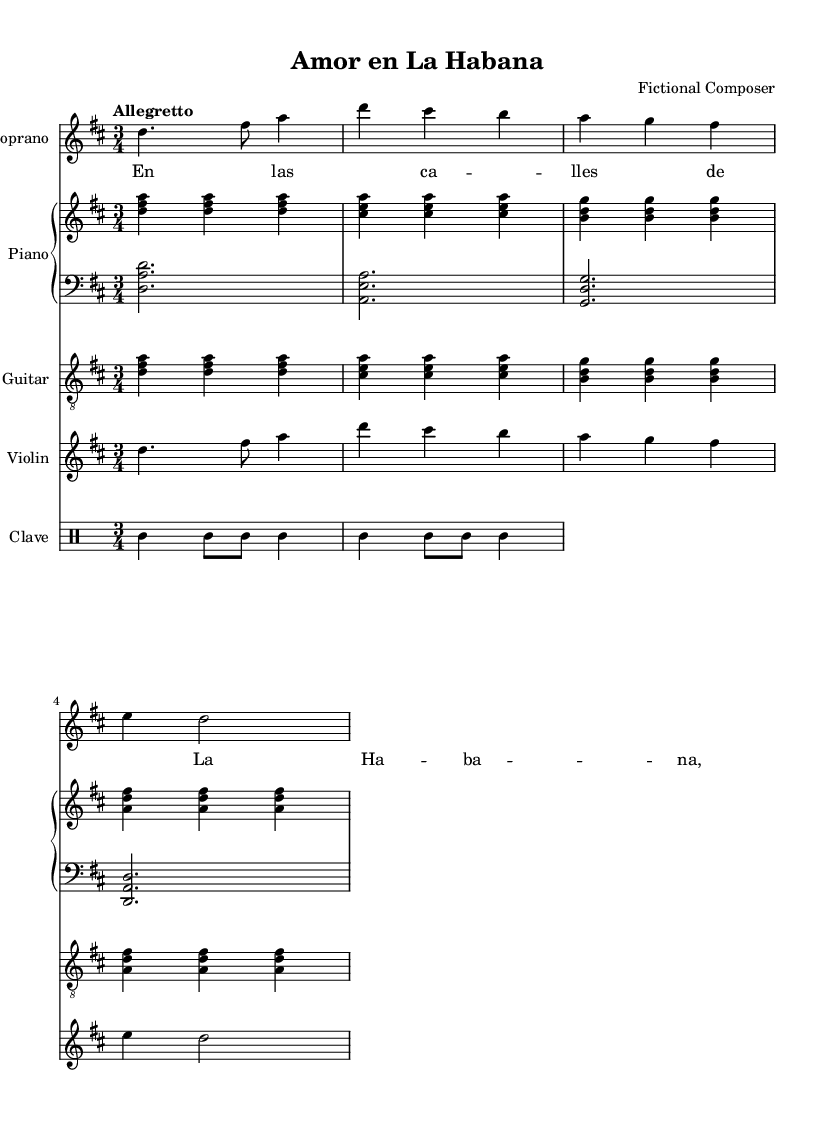What is the key signature of this music? The key signature is indicated at the beginning of the sheet music, which shows two sharps. This means it is in D major or B minor.
Answer: D major What is the time signature of this music? The time signature is shown at the beginning of the sheet music as three beats in a measure, indicated by the "3/4".
Answer: 3/4 What is the tempo marking for the music? The tempo marking is indicated as "Allegretto," which suggests a moderately fast tempo.
Answer: Allegretto How many instruments are in this score? By counting the different staves provided in the score, there are five distinct instruments: Soprano, Piano (two staves), Guitar, Violin, and Clave (Drum Staff).
Answer: Five What is the main thematic element of the opening soprano part? The opening soprano part includes a lyrical line that begins with "En las ca -- lles de La Ha -- ba -- na," showcasing the melodic focus typical in a zarzuela style.
Answer: A lyrical line What genre does this piece belong to? Based on the musical structure, instrumentation, and thematic content, this piece is categorized as a zarzuela, which is a Spanish lyric-dramatic genre combining music, singing, and spoken dialogue.
Answer: Zarzuela 